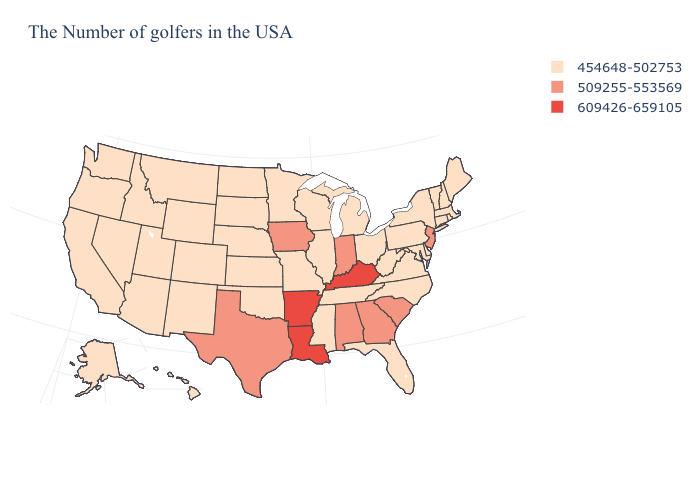What is the lowest value in states that border North Dakota?
Concise answer only. 454648-502753. What is the lowest value in the USA?
Be succinct. 454648-502753. What is the value of California?
Quick response, please. 454648-502753. Among the states that border Texas , which have the highest value?
Answer briefly. Louisiana, Arkansas. What is the highest value in the MidWest ?
Quick response, please. 509255-553569. What is the value of Virginia?
Short answer required. 454648-502753. Among the states that border Georgia , does North Carolina have the highest value?
Concise answer only. No. Name the states that have a value in the range 509255-553569?
Keep it brief. New Jersey, South Carolina, Georgia, Indiana, Alabama, Iowa, Texas. Which states have the lowest value in the USA?
Short answer required. Maine, Massachusetts, Rhode Island, New Hampshire, Vermont, Connecticut, New York, Delaware, Maryland, Pennsylvania, Virginia, North Carolina, West Virginia, Ohio, Florida, Michigan, Tennessee, Wisconsin, Illinois, Mississippi, Missouri, Minnesota, Kansas, Nebraska, Oklahoma, South Dakota, North Dakota, Wyoming, Colorado, New Mexico, Utah, Montana, Arizona, Idaho, Nevada, California, Washington, Oregon, Alaska, Hawaii. What is the highest value in states that border West Virginia?
Give a very brief answer. 609426-659105. Which states have the lowest value in the USA?
Short answer required. Maine, Massachusetts, Rhode Island, New Hampshire, Vermont, Connecticut, New York, Delaware, Maryland, Pennsylvania, Virginia, North Carolina, West Virginia, Ohio, Florida, Michigan, Tennessee, Wisconsin, Illinois, Mississippi, Missouri, Minnesota, Kansas, Nebraska, Oklahoma, South Dakota, North Dakota, Wyoming, Colorado, New Mexico, Utah, Montana, Arizona, Idaho, Nevada, California, Washington, Oregon, Alaska, Hawaii. Does Iowa have the lowest value in the USA?
Give a very brief answer. No. Name the states that have a value in the range 454648-502753?
Concise answer only. Maine, Massachusetts, Rhode Island, New Hampshire, Vermont, Connecticut, New York, Delaware, Maryland, Pennsylvania, Virginia, North Carolina, West Virginia, Ohio, Florida, Michigan, Tennessee, Wisconsin, Illinois, Mississippi, Missouri, Minnesota, Kansas, Nebraska, Oklahoma, South Dakota, North Dakota, Wyoming, Colorado, New Mexico, Utah, Montana, Arizona, Idaho, Nevada, California, Washington, Oregon, Alaska, Hawaii. Which states hav the highest value in the MidWest?
Be succinct. Indiana, Iowa. Among the states that border New Jersey , which have the lowest value?
Be succinct. New York, Delaware, Pennsylvania. 